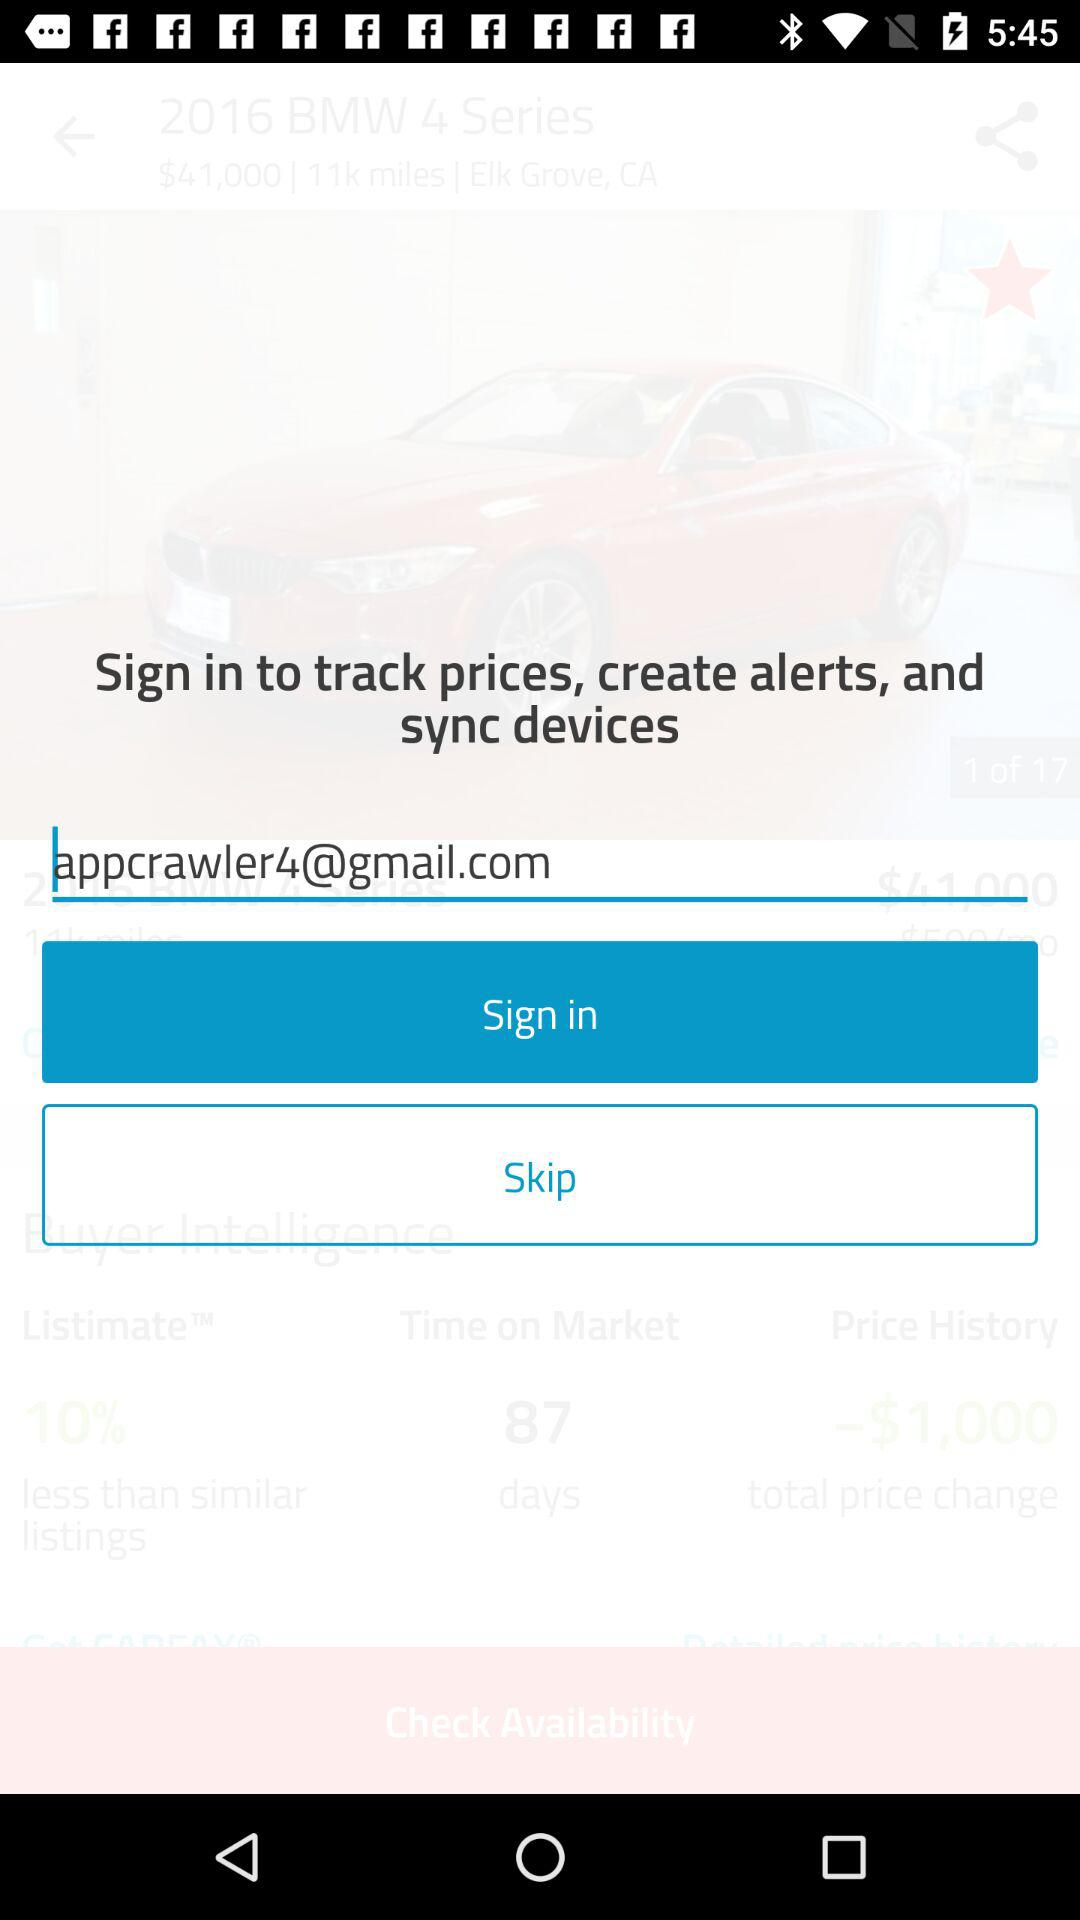What is the email address? The email address is appcrawler4@gmail.com. 